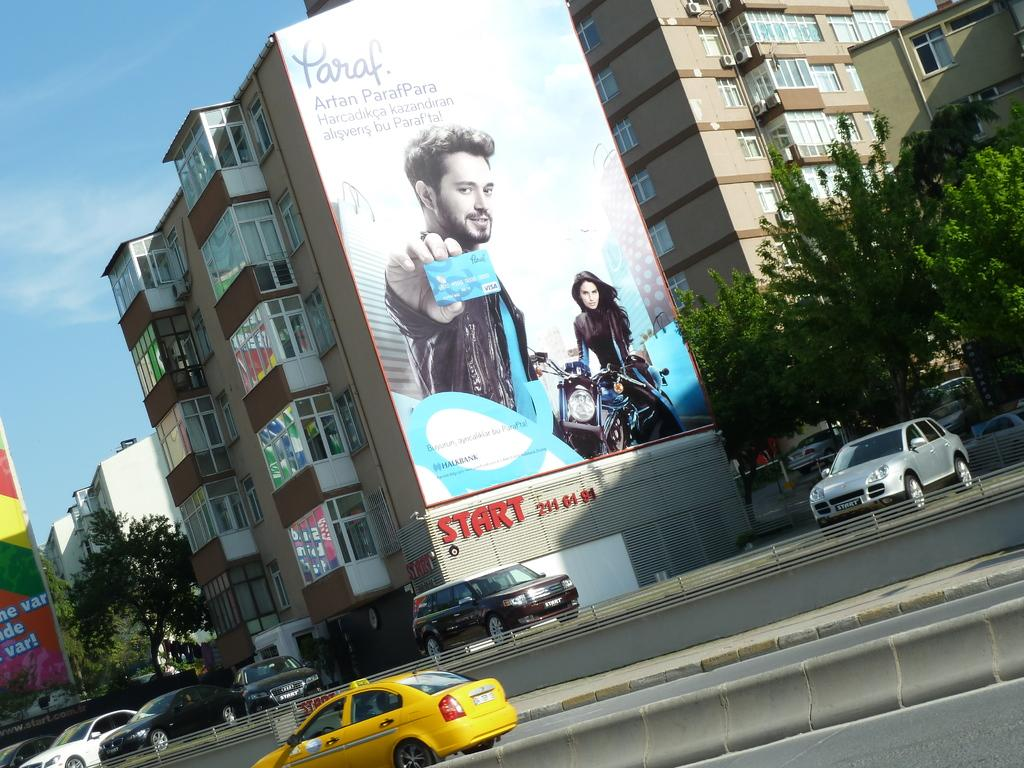What types of objects can be seen in the image? There are vehicles, trees, and a building in the image. What can be seen in the background of the image? The sky is visible in the background of the image. What is attached to the building in the image? There is a huge banner on the building. What type of hair can be seen on the vehicles in the image? There is no hair present on the vehicles in the image. Are there any cherries hanging from the trees in the image? There is no mention of cherries in the image; only trees are mentioned. 